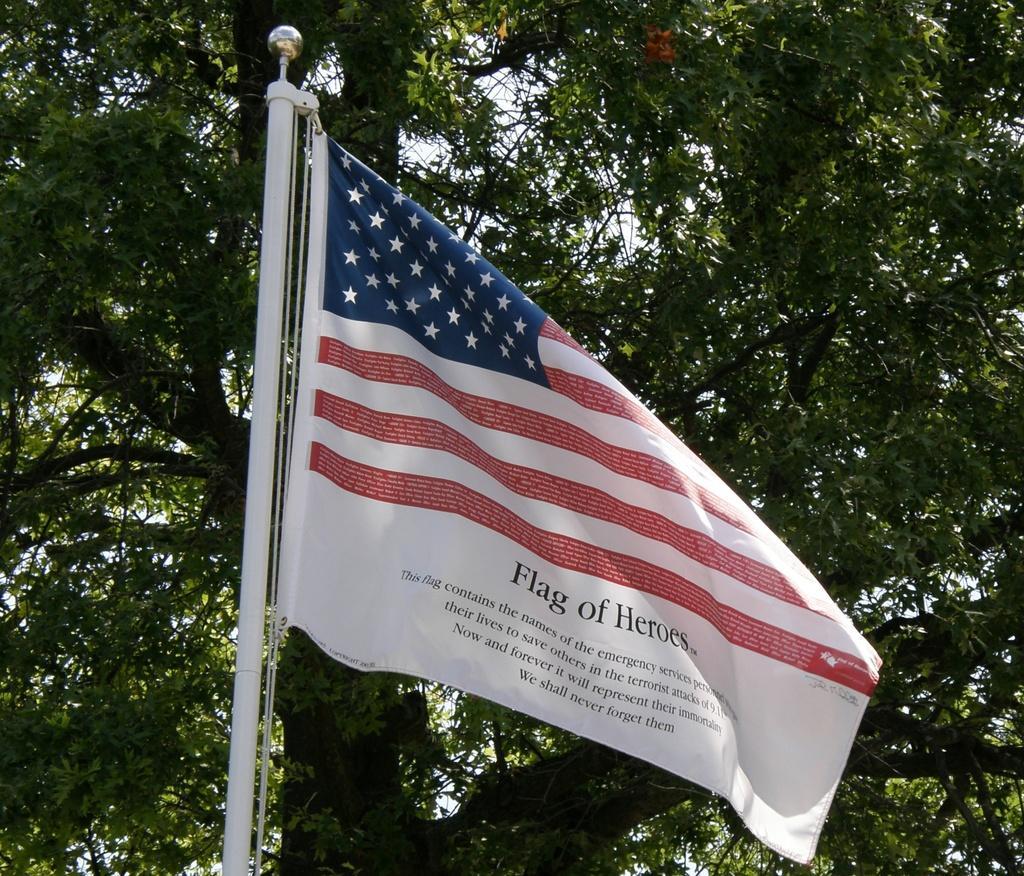In one or two sentences, can you explain what this image depicts? In this image we can see a flag. In the background, we can see a tree. Behind the tree, we can see the sky. 